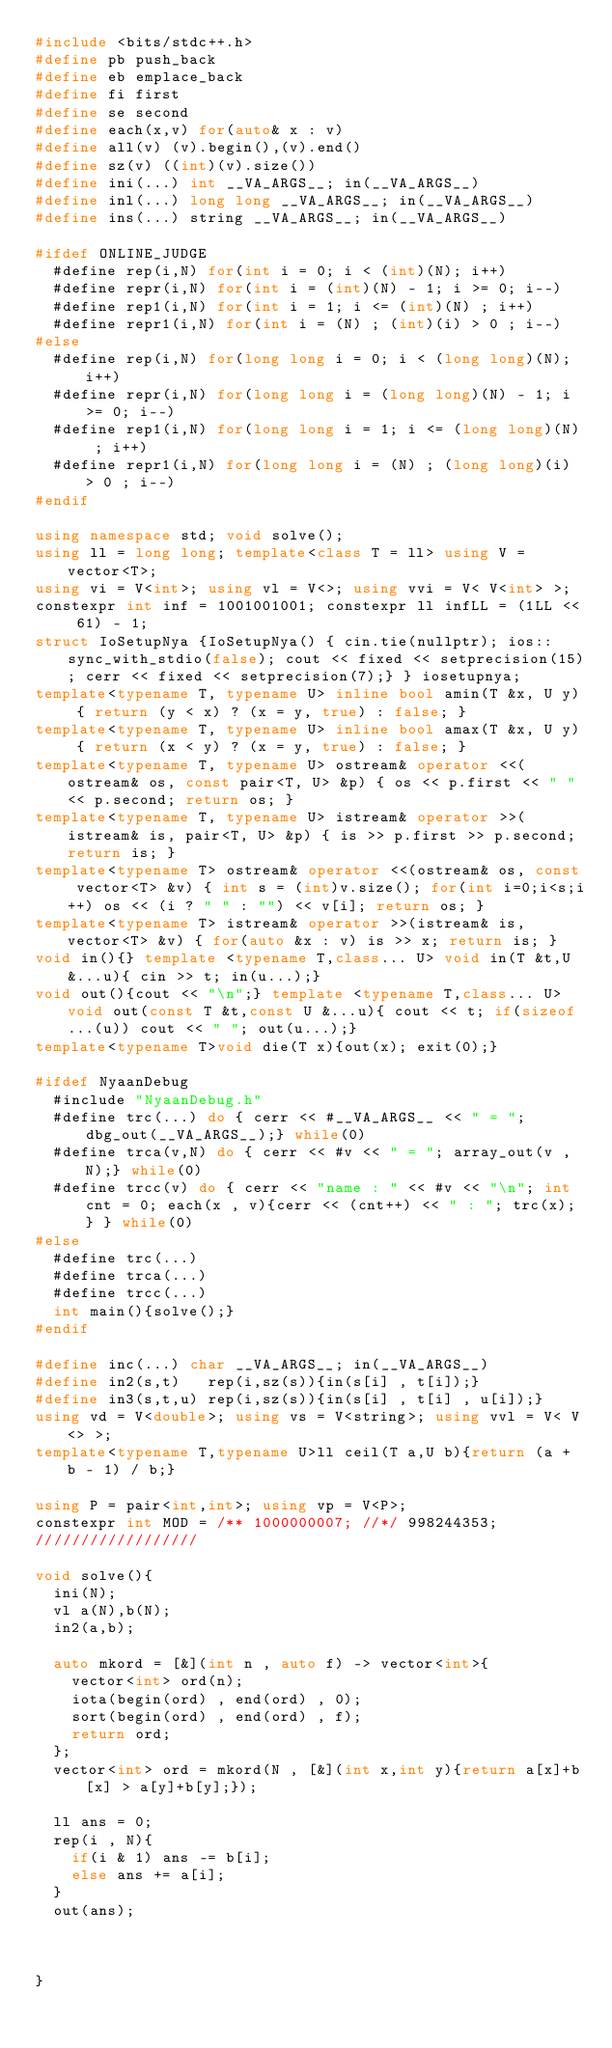<code> <loc_0><loc_0><loc_500><loc_500><_C++_>#include <bits/stdc++.h>
#define pb push_back
#define eb emplace_back
#define fi first
#define se second
#define each(x,v) for(auto& x : v)
#define all(v) (v).begin(),(v).end()
#define sz(v) ((int)(v).size())
#define ini(...) int __VA_ARGS__; in(__VA_ARGS__)
#define inl(...) long long __VA_ARGS__; in(__VA_ARGS__)
#define ins(...) string __VA_ARGS__; in(__VA_ARGS__)

#ifdef ONLINE_JUDGE
  #define rep(i,N) for(int i = 0; i < (int)(N); i++)
  #define repr(i,N) for(int i = (int)(N) - 1; i >= 0; i--)
  #define rep1(i,N) for(int i = 1; i <= (int)(N) ; i++)
  #define repr1(i,N) for(int i = (N) ; (int)(i) > 0 ; i--)
#else
  #define rep(i,N) for(long long i = 0; i < (long long)(N); i++)
  #define repr(i,N) for(long long i = (long long)(N) - 1; i >= 0; i--)
  #define rep1(i,N) for(long long i = 1; i <= (long long)(N) ; i++)
  #define repr1(i,N) for(long long i = (N) ; (long long)(i) > 0 ; i--)
#endif

using namespace std; void solve();
using ll = long long; template<class T = ll> using V = vector<T>;
using vi = V<int>; using vl = V<>; using vvi = V< V<int> >;
constexpr int inf = 1001001001; constexpr ll infLL = (1LL << 61) - 1;
struct IoSetupNya {IoSetupNya() { cin.tie(nullptr); ios::sync_with_stdio(false); cout << fixed << setprecision(15); cerr << fixed << setprecision(7);} } iosetupnya;
template<typename T, typename U> inline bool amin(T &x, U y) { return (y < x) ? (x = y, true) : false; }
template<typename T, typename U> inline bool amax(T &x, U y) { return (x < y) ? (x = y, true) : false; }
template<typename T, typename U> ostream& operator <<(ostream& os, const pair<T, U> &p) { os << p.first << " " << p.second; return os; }
template<typename T, typename U> istream& operator >>(istream& is, pair<T, U> &p) { is >> p.first >> p.second; return is; }
template<typename T> ostream& operator <<(ostream& os, const vector<T> &v) { int s = (int)v.size(); for(int i=0;i<s;i++) os << (i ? " " : "") << v[i]; return os; }
template<typename T> istream& operator >>(istream& is, vector<T> &v) { for(auto &x : v) is >> x; return is; }
void in(){} template <typename T,class... U> void in(T &t,U &...u){ cin >> t; in(u...);}
void out(){cout << "\n";} template <typename T,class... U> void out(const T &t,const U &...u){ cout << t; if(sizeof...(u)) cout << " "; out(u...);}
template<typename T>void die(T x){out(x); exit(0);}

#ifdef NyaanDebug
  #include "NyaanDebug.h"
  #define trc(...) do { cerr << #__VA_ARGS__ << " = "; dbg_out(__VA_ARGS__);} while(0)
  #define trca(v,N) do { cerr << #v << " = "; array_out(v , N);} while(0)
  #define trcc(v) do { cerr << "name : " << #v << "\n"; int cnt = 0; each(x , v){cerr << (cnt++) << " : "; trc(x); } } while(0)
#else
  #define trc(...)
  #define trca(...)
  #define trcc(...)
  int main(){solve();}
#endif

#define inc(...) char __VA_ARGS__; in(__VA_ARGS__)
#define in2(s,t)   rep(i,sz(s)){in(s[i] , t[i]);}
#define in3(s,t,u) rep(i,sz(s)){in(s[i] , t[i] , u[i]);}
using vd = V<double>; using vs = V<string>; using vvl = V< V<> >;
template<typename T,typename U>ll ceil(T a,U b){return (a + b - 1) / b;}

using P = pair<int,int>; using vp = V<P>;
constexpr int MOD = /** 1000000007; //*/ 998244353;
//////////////////

void solve(){
  ini(N);
  vl a(N),b(N);
  in2(a,b);

  auto mkord = [&](int n , auto f) -> vector<int>{
    vector<int> ord(n);
    iota(begin(ord) , end(ord) , 0);
    sort(begin(ord) , end(ord) , f);
    return ord;
  };
  vector<int> ord = mkord(N , [&](int x,int y){return a[x]+b[x] > a[y]+b[y];});

  ll ans = 0;
  rep(i , N){
    if(i & 1) ans -= b[i];
    else ans += a[i];
  }
  out(ans);

  

}</code> 